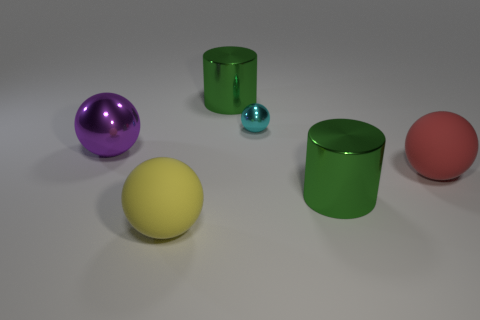Is there any other thing that is the same size as the cyan metallic sphere?
Offer a very short reply. No. How many things are either large matte spheres that are left of the red object or tiny metallic spheres?
Offer a terse response. 2. The cyan thing that is to the right of the cylinder that is left of the tiny cyan sphere is what shape?
Make the answer very short. Sphere. Is the size of the yellow ball the same as the metallic ball on the right side of the yellow matte thing?
Keep it short and to the point. No. There is a large ball that is right of the cyan ball; what is it made of?
Offer a very short reply. Rubber. What number of large objects are in front of the purple ball and on the right side of the big yellow thing?
Your answer should be compact. 2. What is the material of the purple object that is the same size as the red rubber ball?
Provide a succinct answer. Metal. There is a cylinder that is behind the purple object; does it have the same size as the metal sphere that is on the left side of the big yellow sphere?
Your answer should be compact. Yes. There is a large metal ball; are there any cylinders in front of it?
Offer a terse response. Yes. What color is the large cylinder in front of the big cylinder behind the big red object?
Ensure brevity in your answer.  Green. 